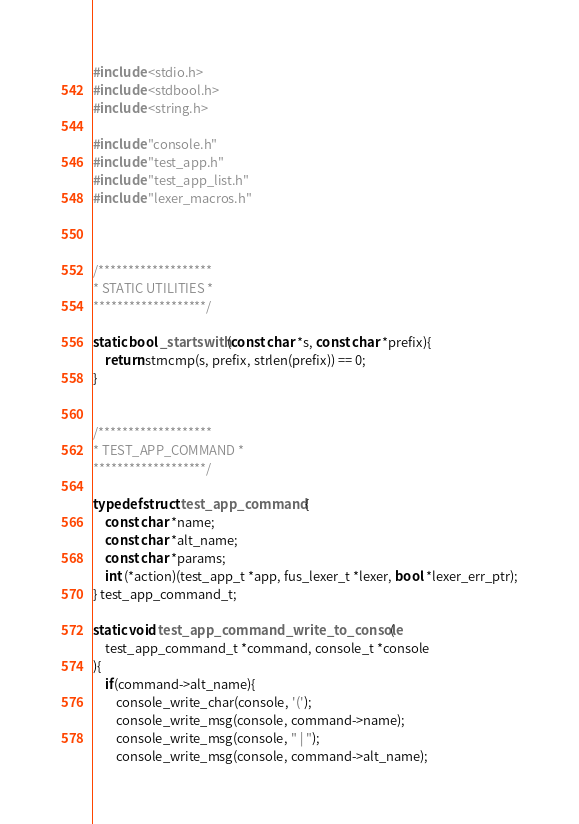<code> <loc_0><loc_0><loc_500><loc_500><_C_>
#include <stdio.h>
#include <stdbool.h>
#include <string.h>

#include "console.h"
#include "test_app.h"
#include "test_app_list.h"
#include "lexer_macros.h"



/*******************
* STATIC UTILITIES *
*******************/

static bool _startswith(const char *s, const char *prefix){
    return strncmp(s, prefix, strlen(prefix)) == 0;
}


/*******************
* TEST_APP_COMMAND *
*******************/

typedef struct test_app_command {
    const char *name;
    const char *alt_name;
    const char *params;
    int (*action)(test_app_t *app, fus_lexer_t *lexer, bool *lexer_err_ptr);
} test_app_command_t;

static void test_app_command_write_to_console(
    test_app_command_t *command, console_t *console
){
    if(command->alt_name){
        console_write_char(console, '(');
        console_write_msg(console, command->name);
        console_write_msg(console, " | ");
        console_write_msg(console, command->alt_name);</code> 